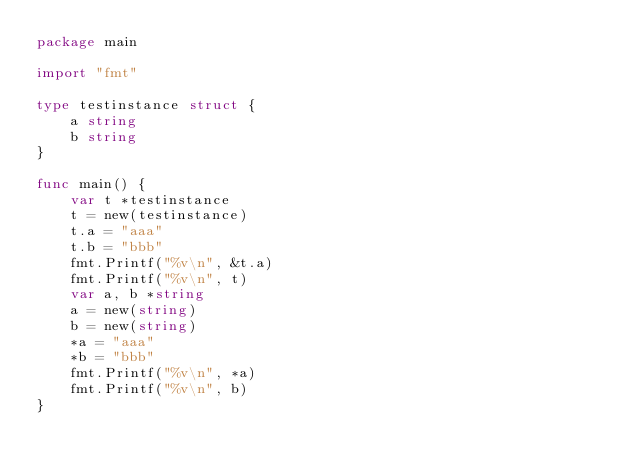Convert code to text. <code><loc_0><loc_0><loc_500><loc_500><_Go_>package main

import "fmt"

type testinstance struct {
	a string
	b string
}

func main() {
	var t *testinstance
	t = new(testinstance)
	t.a = "aaa"
	t.b = "bbb"
	fmt.Printf("%v\n", &t.a)
	fmt.Printf("%v\n", t)
	var a, b *string
	a = new(string)
	b = new(string)
	*a = "aaa"
	*b = "bbb"
	fmt.Printf("%v\n", *a)
	fmt.Printf("%v\n", b)
}
</code> 